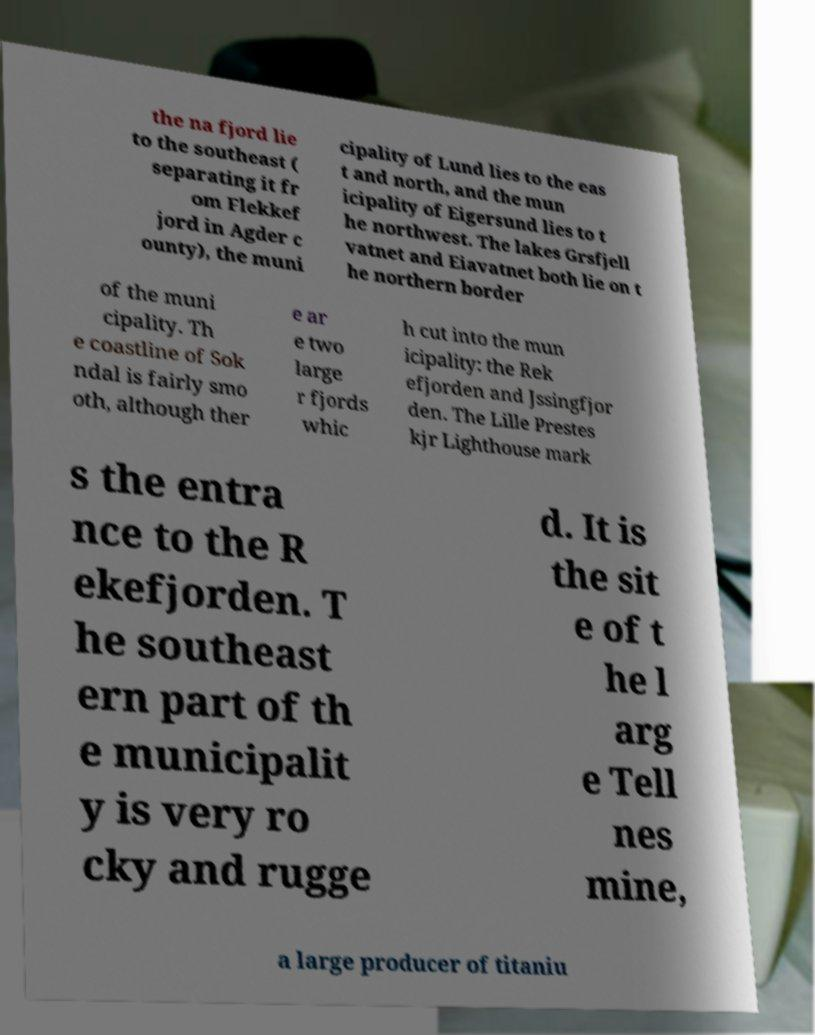What messages or text are displayed in this image? I need them in a readable, typed format. the na fjord lie to the southeast ( separating it fr om Flekkef jord in Agder c ounty), the muni cipality of Lund lies to the eas t and north, and the mun icipality of Eigersund lies to t he northwest. The lakes Grsfjell vatnet and Eiavatnet both lie on t he northern border of the muni cipality. Th e coastline of Sok ndal is fairly smo oth, although ther e ar e two large r fjords whic h cut into the mun icipality: the Rek efjorden and Jssingfjor den. The Lille Prestes kjr Lighthouse mark s the entra nce to the R ekefjorden. T he southeast ern part of th e municipalit y is very ro cky and rugge d. It is the sit e of t he l arg e Tell nes mine, a large producer of titaniu 